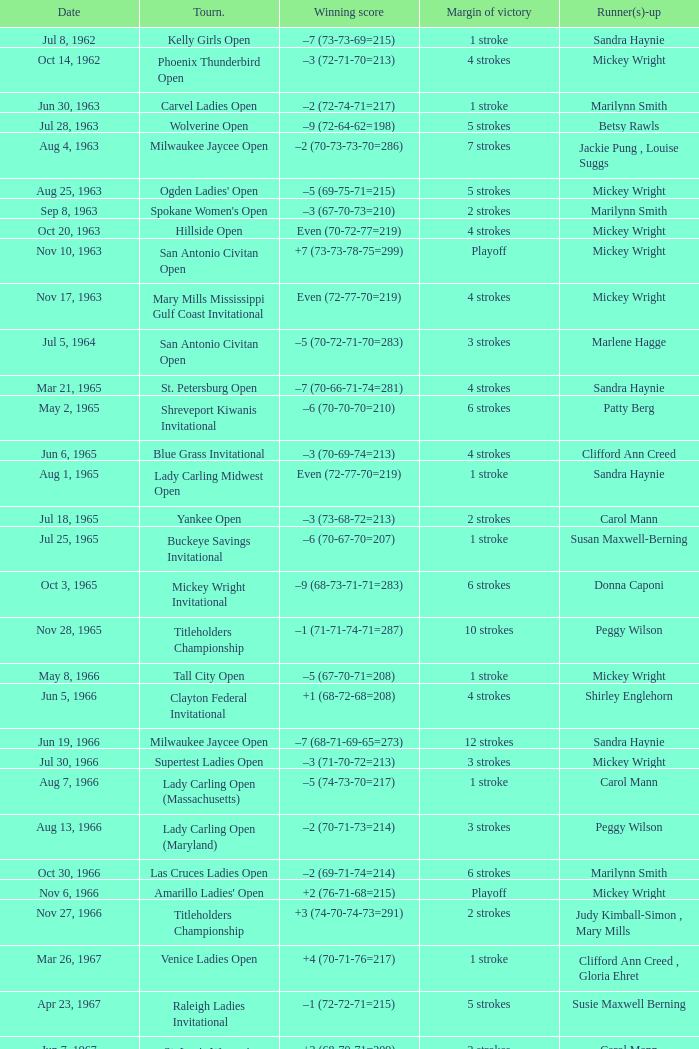What was the winning score when there were 9 strokes advantage? –7 (73-68-73-67=281). 